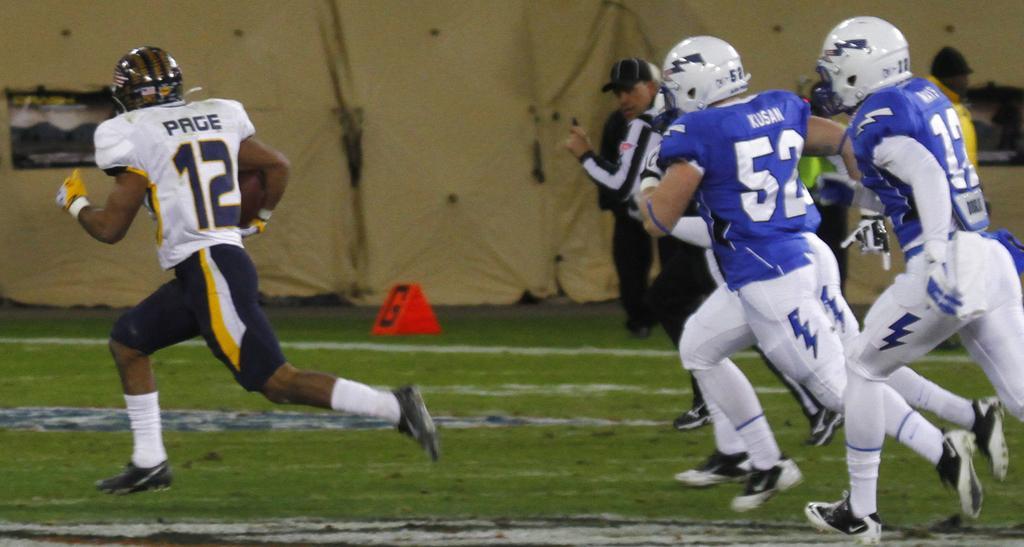Can you describe this image briefly? In this image there are four men running, there are three men wearing helmets, there are two men wearing caps, there is grass towards the bottom of the image, there is an object on the grass, at the background of the image there is an object that looks like a curtain. 